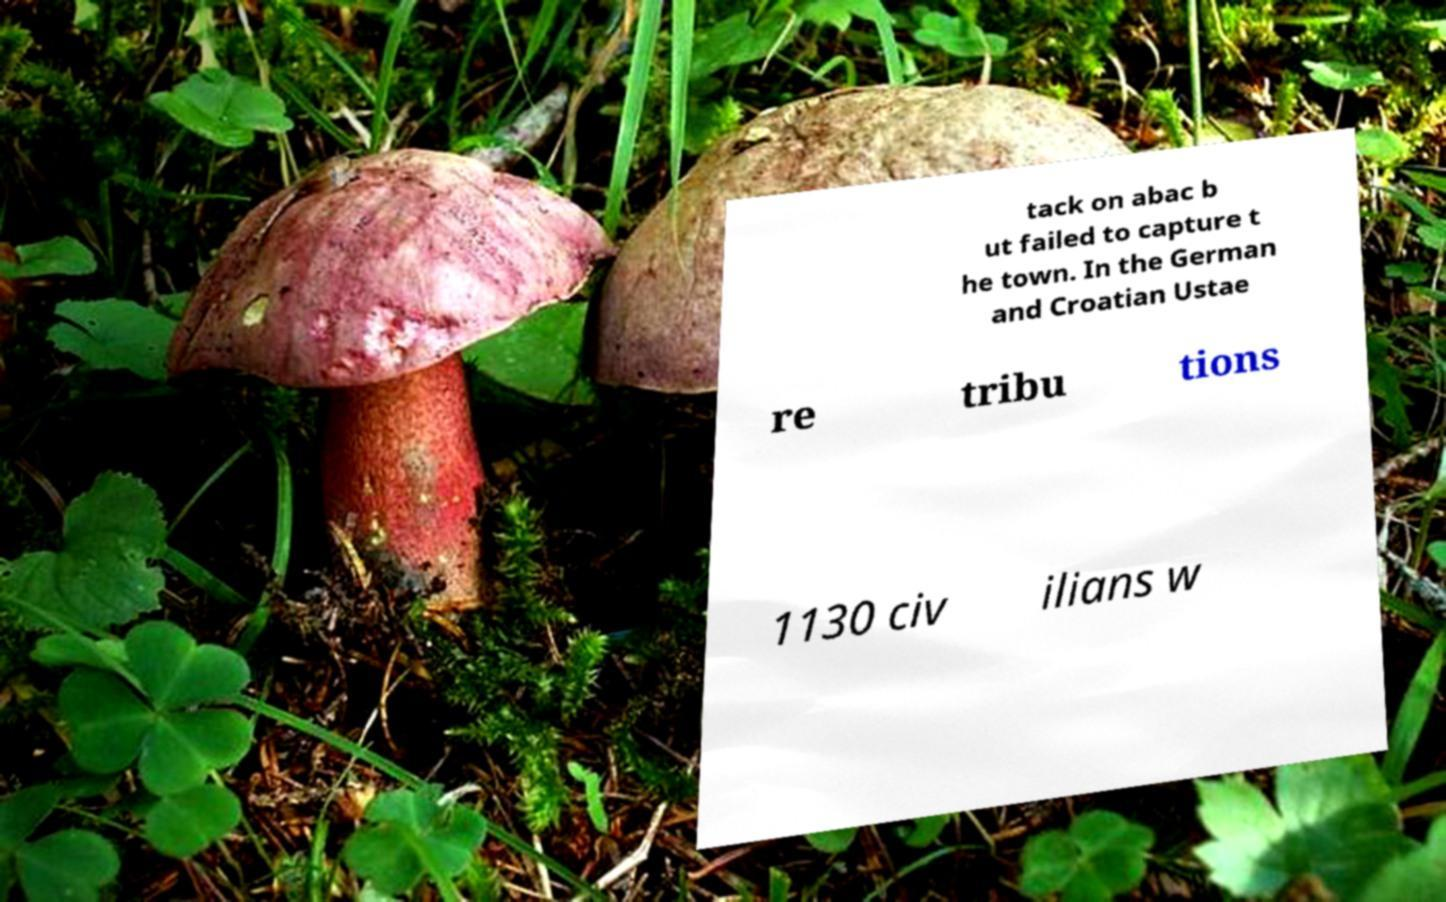There's text embedded in this image that I need extracted. Can you transcribe it verbatim? tack on abac b ut failed to capture t he town. In the German and Croatian Ustae re tribu tions 1130 civ ilians w 